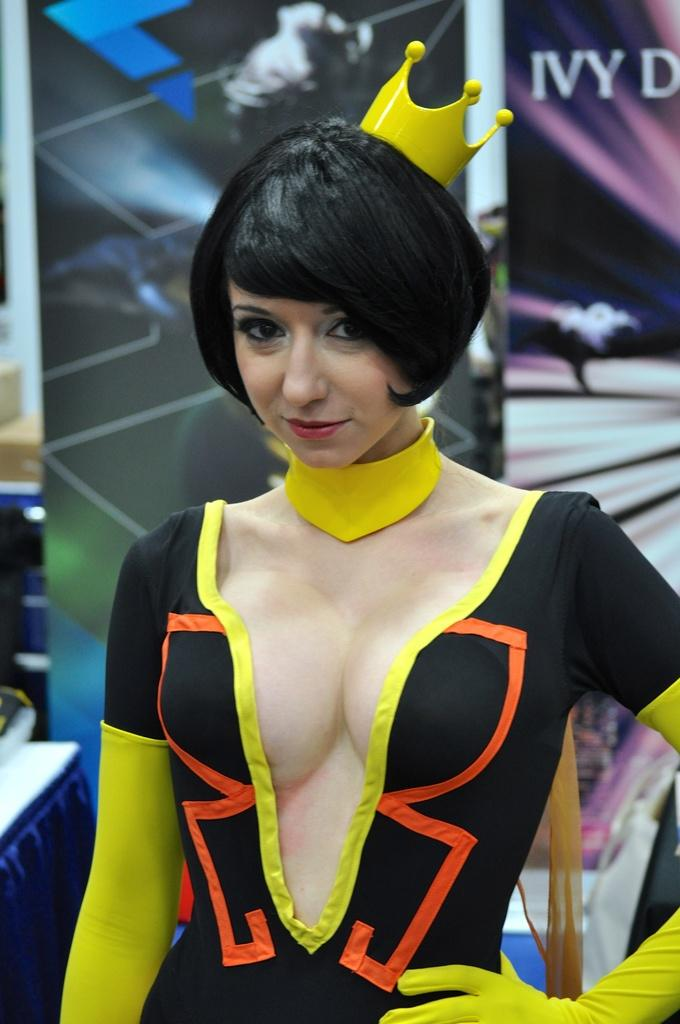<image>
Summarize the visual content of the image. A woman in a skimpy costume posing in front of a backdrop that says Ivy 